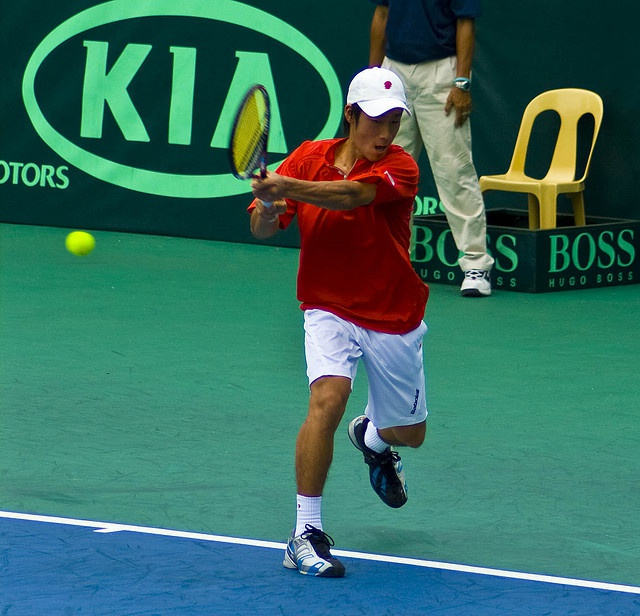Describe the objects in this image and their specific colors. I can see people in black, maroon, lightgray, and gray tones, people in black, darkgray, gray, and maroon tones, chair in black, khaki, gold, and olive tones, tennis racket in black, olive, and gray tones, and sports ball in black, lime, yellow, and green tones in this image. 